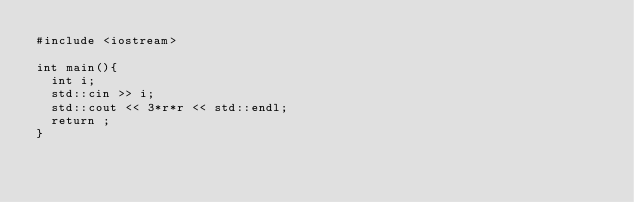Convert code to text. <code><loc_0><loc_0><loc_500><loc_500><_C++_>#include <iostream>

int main(){
  int i;
  std::cin >> i;
  std::cout << 3*r*r << std::endl;
  return ;
}</code> 